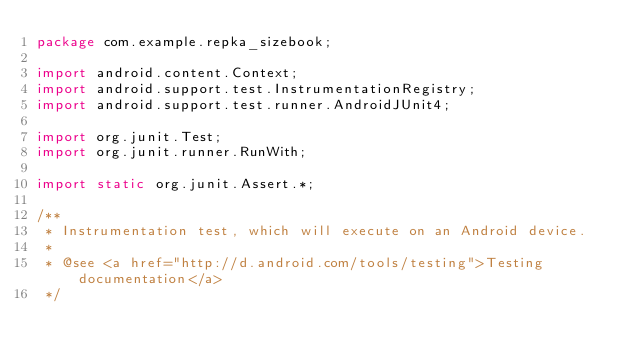<code> <loc_0><loc_0><loc_500><loc_500><_Java_>package com.example.repka_sizebook;

import android.content.Context;
import android.support.test.InstrumentationRegistry;
import android.support.test.runner.AndroidJUnit4;

import org.junit.Test;
import org.junit.runner.RunWith;

import static org.junit.Assert.*;

/**
 * Instrumentation test, which will execute on an Android device.
 *
 * @see <a href="http://d.android.com/tools/testing">Testing documentation</a>
 */</code> 